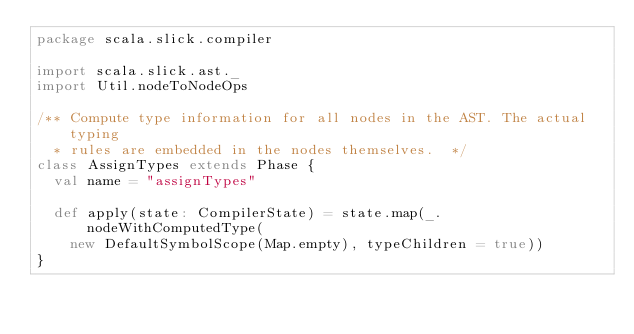<code> <loc_0><loc_0><loc_500><loc_500><_Scala_>package scala.slick.compiler

import scala.slick.ast._
import Util.nodeToNodeOps

/** Compute type information for all nodes in the AST. The actual typing
  * rules are embedded in the nodes themselves.  */
class AssignTypes extends Phase {
  val name = "assignTypes"

  def apply(state: CompilerState) = state.map(_.nodeWithComputedType(
    new DefaultSymbolScope(Map.empty), typeChildren = true))
}
</code> 